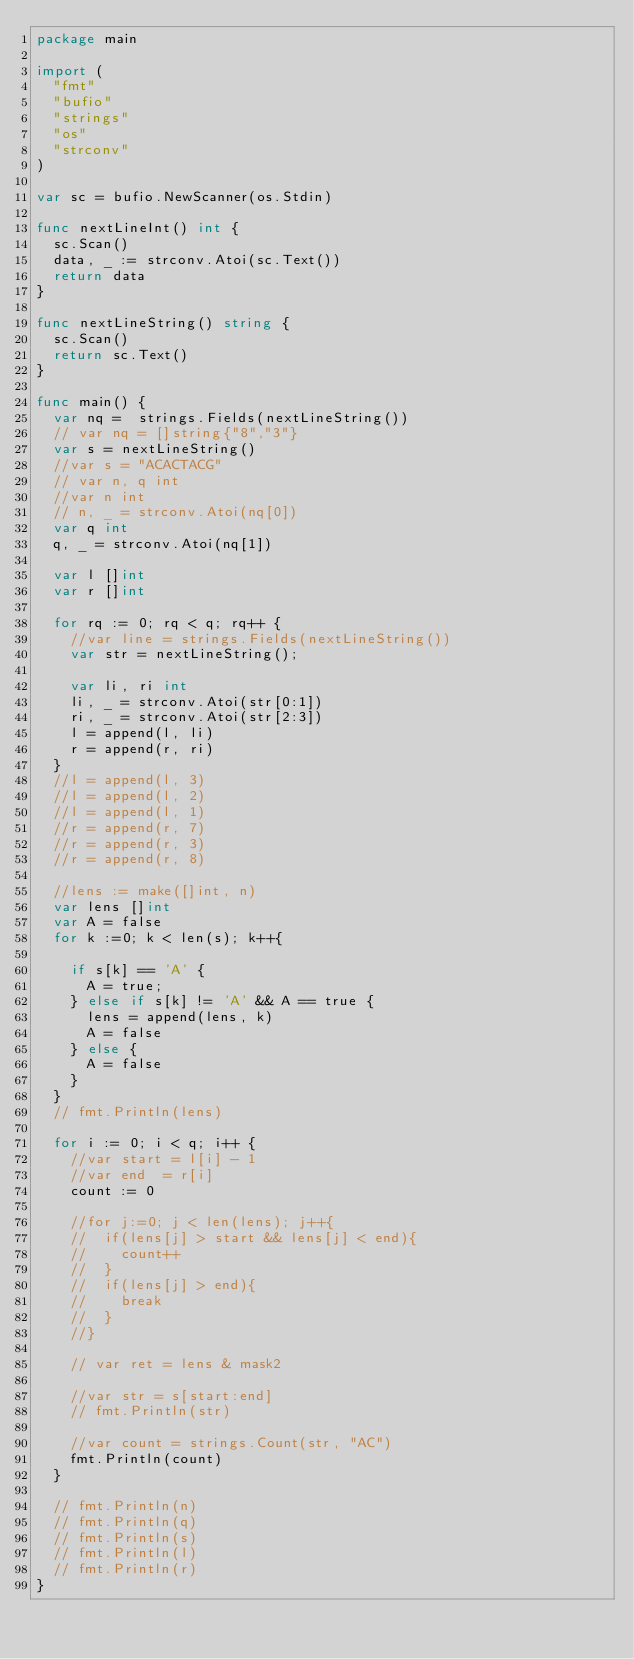Convert code to text. <code><loc_0><loc_0><loc_500><loc_500><_Go_>package main

import (
  "fmt"
  "bufio"
  "strings"
  "os"
  "strconv"
)

var sc = bufio.NewScanner(os.Stdin)

func nextLineInt() int {
  sc.Scan()
  data, _ := strconv.Atoi(sc.Text())
  return data
}

func nextLineString() string {
  sc.Scan()
  return sc.Text()
}

func main() {
  var nq =  strings.Fields(nextLineString())
  // var nq = []string{"8","3"}
  var s = nextLineString()
  //var s = "ACACTACG"
  // var n, q int
  //var n int
  // n, _ = strconv.Atoi(nq[0])
  var q int
  q, _ = strconv.Atoi(nq[1])

  var l []int
  var r []int

  for rq := 0; rq < q; rq++ {
    //var line = strings.Fields(nextLineString())
    var str = nextLineString();

    var li, ri int
    li, _ = strconv.Atoi(str[0:1])
    ri, _ = strconv.Atoi(str[2:3])
    l = append(l, li)
    r = append(r, ri)
  }
  //l = append(l, 3)
  //l = append(l, 2)
  //l = append(l, 1)
  //r = append(r, 7)
  //r = append(r, 3)
  //r = append(r, 8)

  //lens := make([]int, n)
  var lens []int
  var A = false
  for k :=0; k < len(s); k++{

    if s[k] == 'A' {
      A = true;
    } else if s[k] != 'A' && A == true {
      lens = append(lens, k)
      A = false
    } else {
      A = false
    }
  }
  // fmt.Println(lens)

  for i := 0; i < q; i++ {
    //var start = l[i] - 1
    //var end  = r[i]
    count := 0

    //for j:=0; j < len(lens); j++{
    //  if(lens[j] > start && lens[j] < end){
    //    count++
    //  }
    //  if(lens[j] > end){
    //    break
    //  }
    //}

    // var ret = lens & mask2

    //var str = s[start:end]
    // fmt.Println(str)

    //var count = strings.Count(str, "AC")
    fmt.Println(count)
  }

  // fmt.Println(n)
  // fmt.Println(q)
  // fmt.Println(s)
  // fmt.Println(l)
  // fmt.Println(r)
}
</code> 